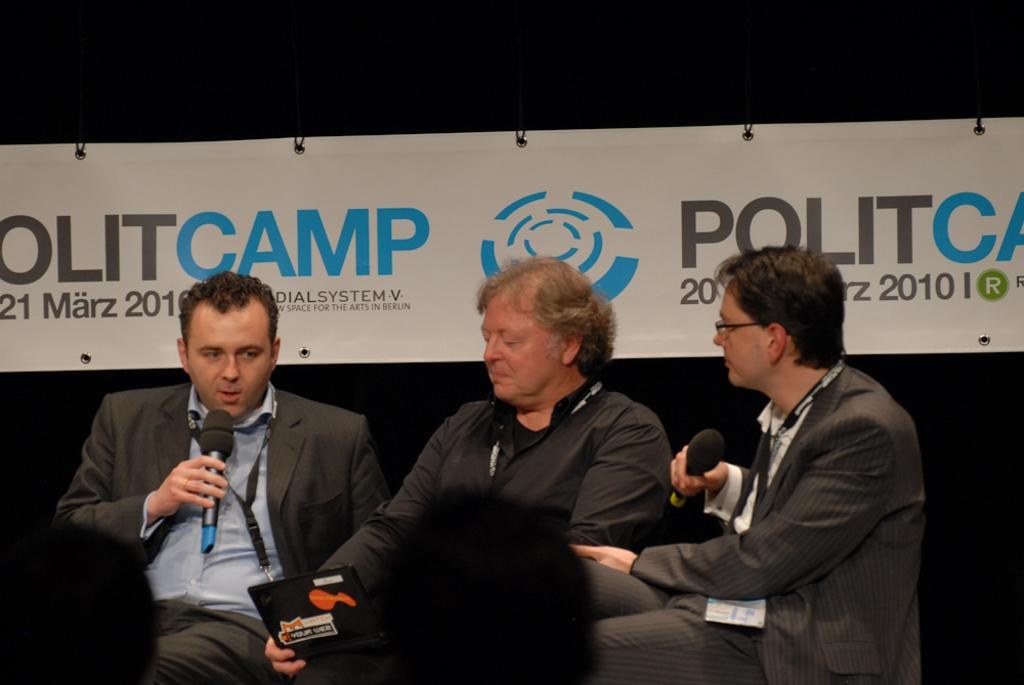How many people are in the image? There are three persons in the image. What are the persons doing in the image? The persons are sitting on chairs and holding microphones in their hands. What can be seen in the background of the image? There is a banner in the background of the image. What type of mine is visible in the image? There is no mine present in the image; it features three persons sitting on chairs and holding microphones. What organization do the persons in the image represent? The image does not provide any information about the organization the persons might represent. 